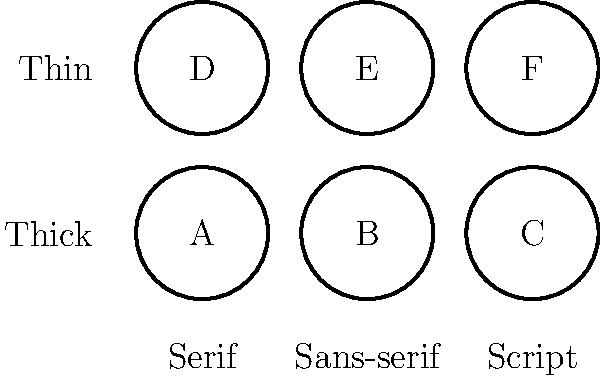As a CSS enthusiast and career designer, you're working on a machine learning model to classify fonts. Given the visual characteristics shown in the image, which font would most likely be classified as a thin, sans-serif typeface? To answer this question, let's analyze the visual characteristics presented in the image:

1. The image shows a 2x3 grid of font samples, labeled A through F.
2. The x-axis is categorized into three font styles: Serif, Sans-serif, and Script.
3. The y-axis represents stroke weight: Thick (bottom row) and Thin (top row).

Now, let's break down the classification process:

1. We're looking for a thin typeface, so we'll focus on the top row (D, E, F).
2. Among the font styles, we specifically need a sans-serif typeface.
3. Sans-serif fonts are in the middle column of the grid.

Combining these criteria, we can conclude that the font that best matches a thin, sans-serif typeface would be the one located in the top-middle position of the grid.

This corresponds to the font labeled 'E' in the image.
Answer: E 